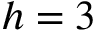<formula> <loc_0><loc_0><loc_500><loc_500>h = 3</formula> 